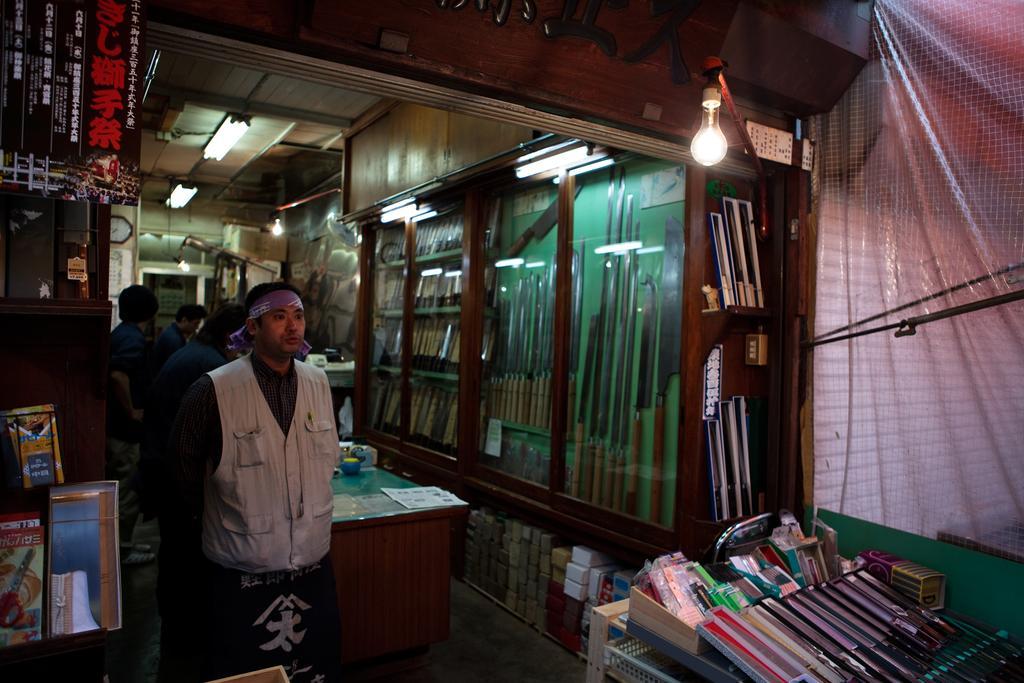In one or two sentences, can you explain what this image depicts? There is a person standing. Beside him, there are many materials on the table. In the background, there is a light, knives arranged in shelf covered with glass. Top this, there are lights, wall, other items and persons. 